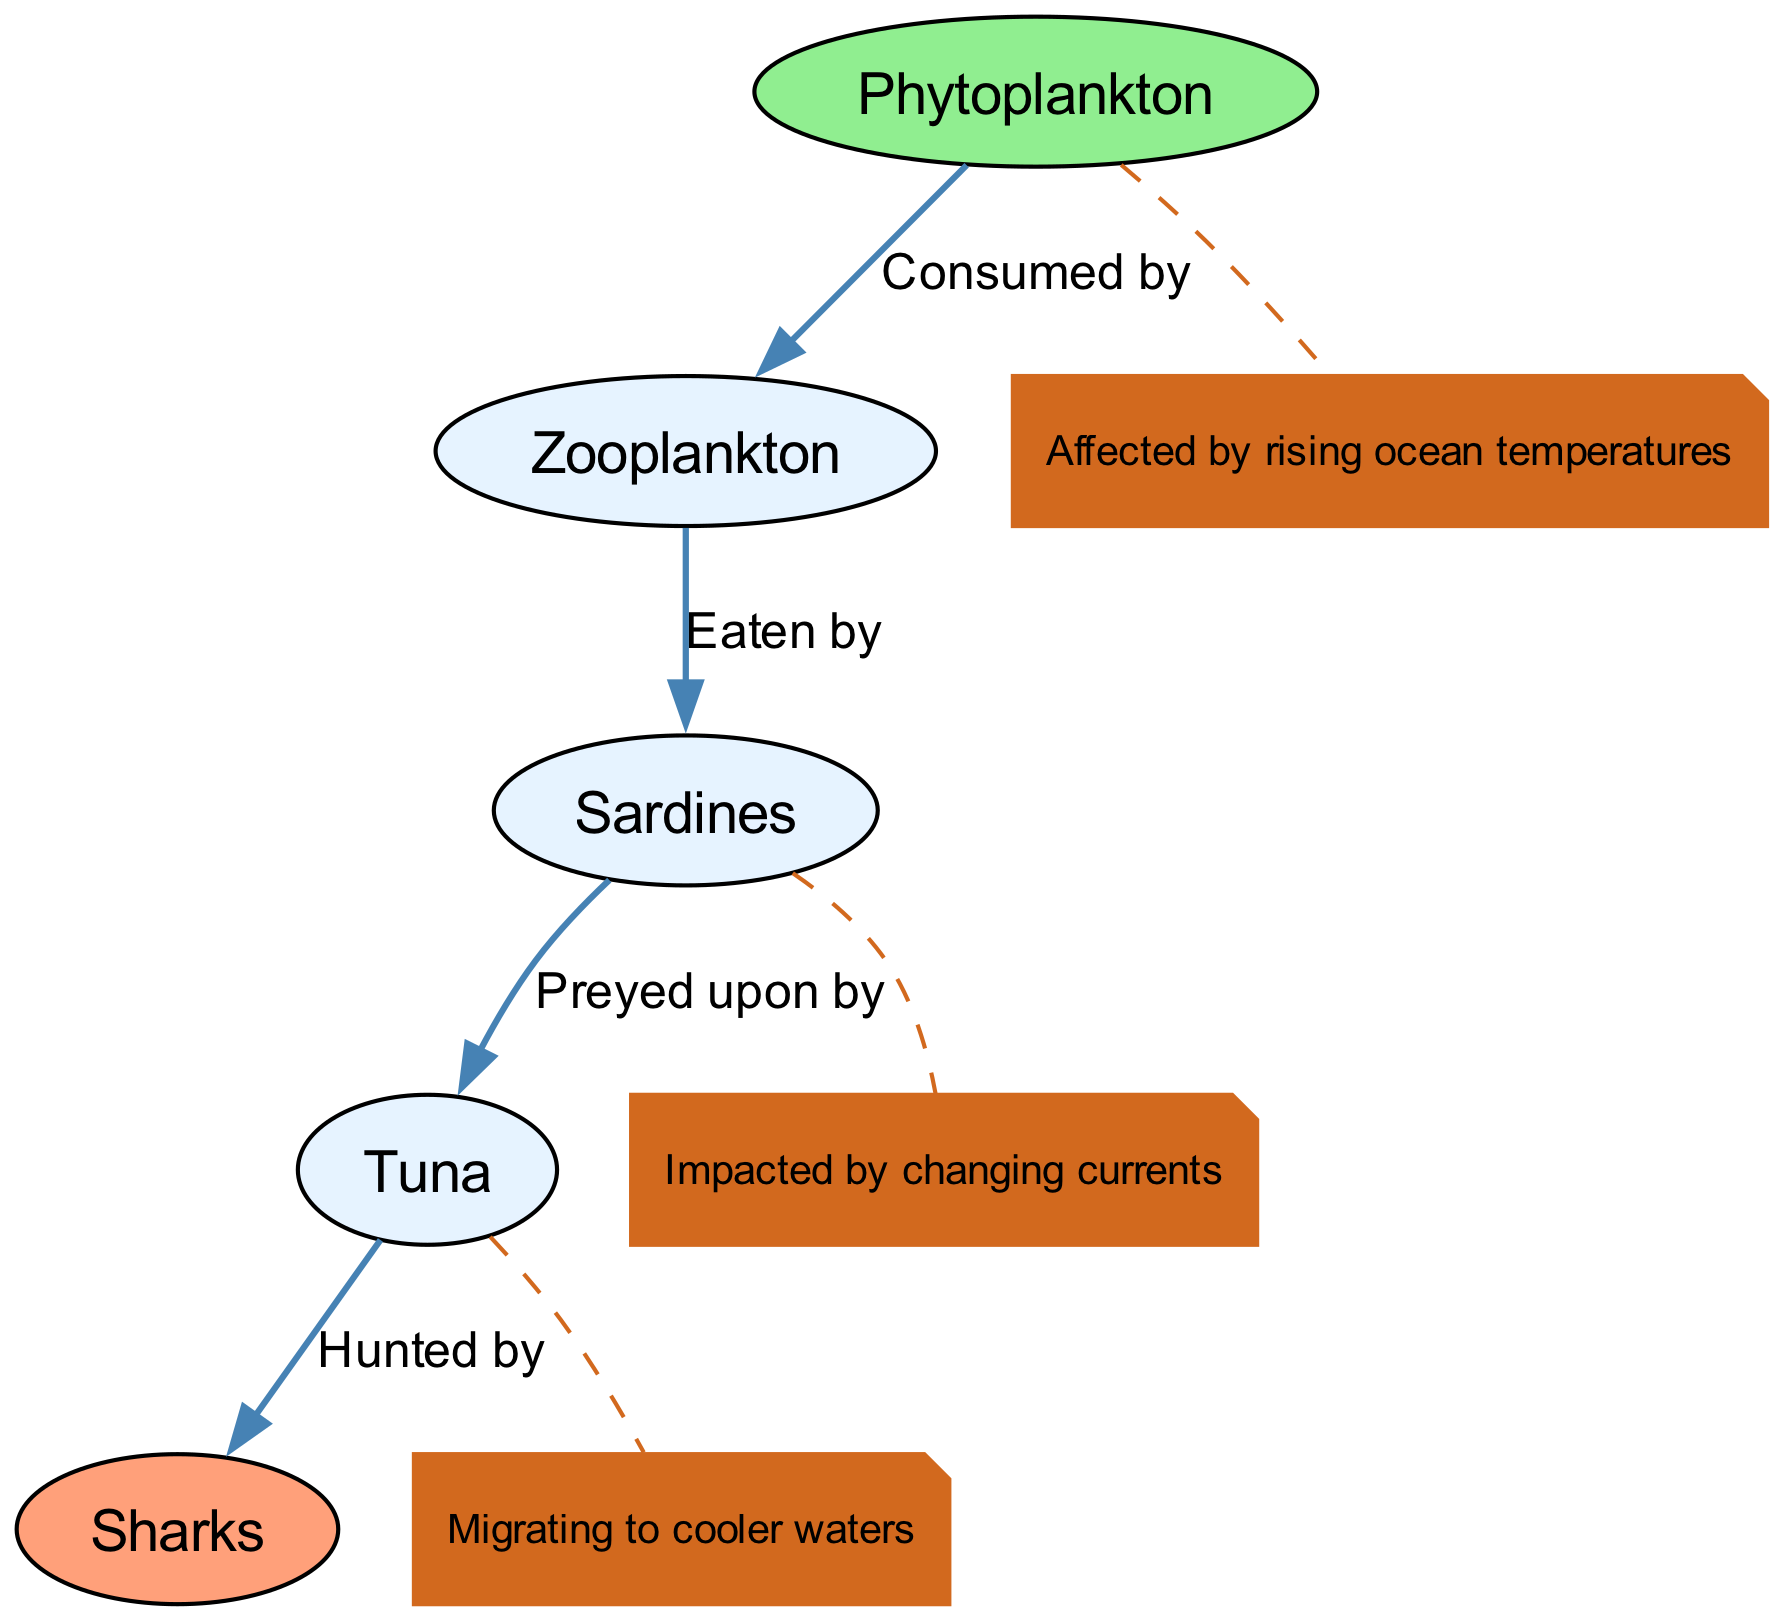What is the first node in the food chain? The first node in the food chain diagram is "Phytoplankton." It is located at the top of the diagram and is the starting point for the flow of energy through the food chain.
Answer: Phytoplankton How many nodes are present in the diagram? The diagram contains a total of five nodes: "Phytoplankton," "Zooplankton," "Sardines," "Tuna," and "Sharks." This is determined by counting each unique entity listed in the nodes section of the data.
Answer: 5 Which organism is eaten by sardines? The organism that is eaten by sardines is "Zooplankton." This relationship is indicated by the directed edge from "Zooplankton" to "Sardines" in the diagram, which specifies that sardines consume zooplankton.
Answer: Zooplankton What effect do rising ocean temperatures have on phytoplankton? Rising ocean temperatures affect phytoplankton by impacting their growth and distribution. The diagram specifically annotates "Phytoplankton" with the note stating they are "Affected by rising ocean temperatures."
Answer: Affected by rising ocean temperatures Which organisms are migratory in response to climate changes? The organism that is known to migrate in response to climate changes is "Tuna," as noted in the diagram. The annotation for "Tuna" indicates it is "Migrating to cooler waters."
Answer: Tuna What type of relationship exists between sardines and tuna? The relationship that exists between sardines and tuna is a predatory one, where tuna prey on sardines. This is indicated by the labeled edge from "Sardines" to "Tuna" stating "Preyed upon by."
Answer: Preyed upon by How does climate change affect sardines? Climate change impacts sardines by altering their environment, specifically changing the currents. This is clearly annotated in the diagram next to the "Sardines" node.
Answer: Impacted by changing currents Which node is at the top of the hierarchy in the food chain? The node at the top of the hierarchy in the food chain is "Sharks." In food chain diagrams, apex predators like sharks are typically positioned at the top, as they are the final consumers in this specific chain.
Answer: Sharks How is the flow of energy represented in the diagram? The flow of energy in the diagram is represented by directed edges that show which organisms consume others. For instance, the path from "Phytoplankton" to "Zooplankton" indicates energy transfer, with phytoplankton being the primary producers.
Answer: Directed edges 